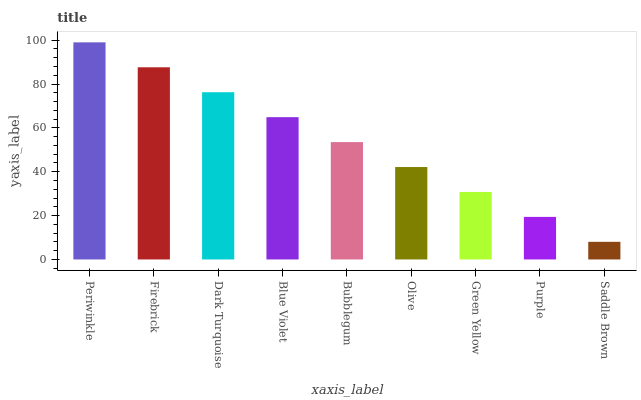Is Saddle Brown the minimum?
Answer yes or no. Yes. Is Periwinkle the maximum?
Answer yes or no. Yes. Is Firebrick the minimum?
Answer yes or no. No. Is Firebrick the maximum?
Answer yes or no. No. Is Periwinkle greater than Firebrick?
Answer yes or no. Yes. Is Firebrick less than Periwinkle?
Answer yes or no. Yes. Is Firebrick greater than Periwinkle?
Answer yes or no. No. Is Periwinkle less than Firebrick?
Answer yes or no. No. Is Bubblegum the high median?
Answer yes or no. Yes. Is Bubblegum the low median?
Answer yes or no. Yes. Is Periwinkle the high median?
Answer yes or no. No. Is Olive the low median?
Answer yes or no. No. 